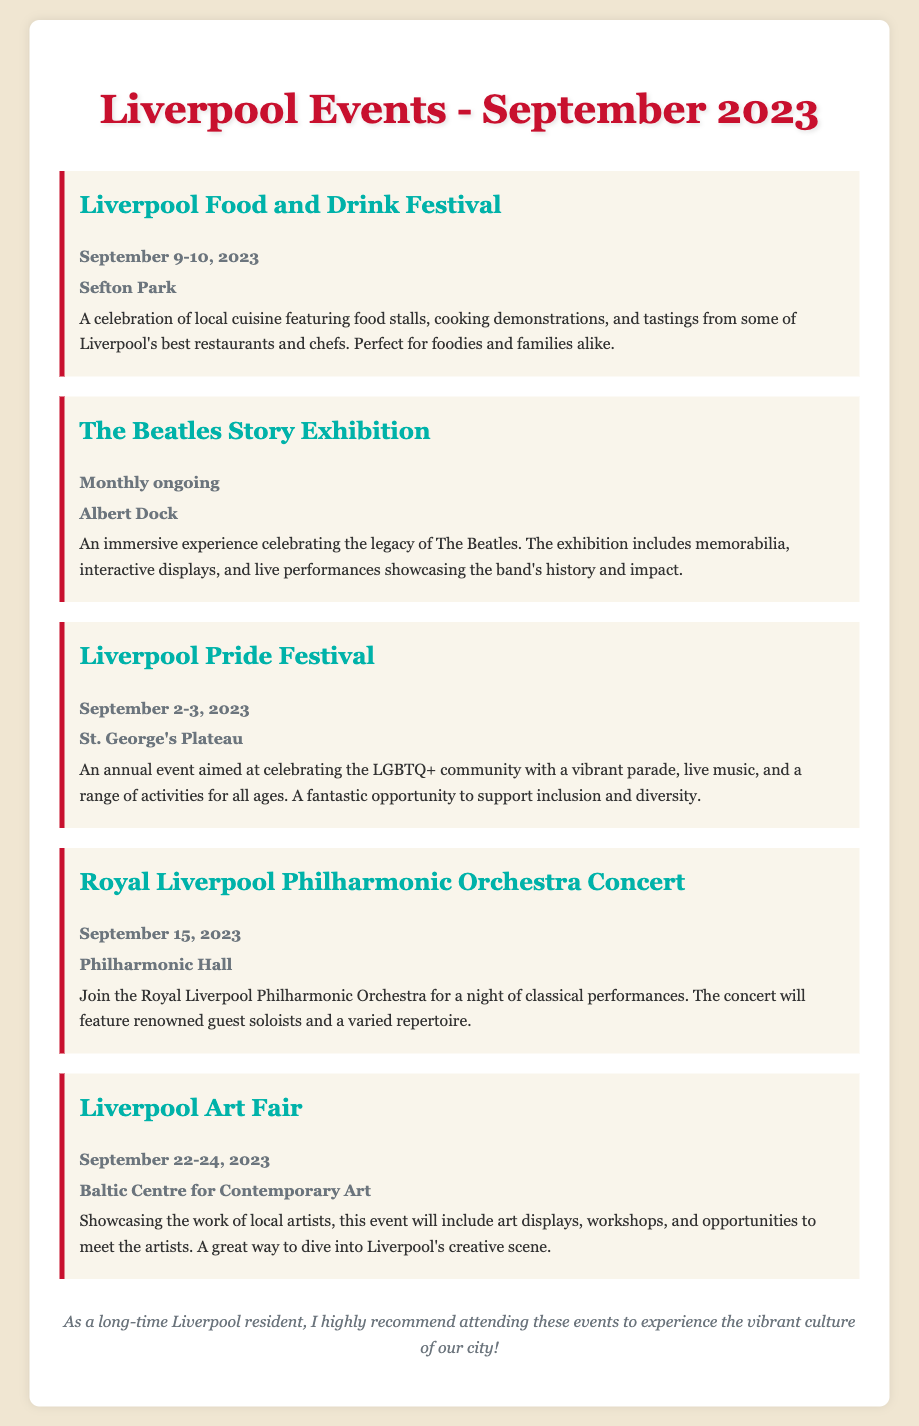What event is taking place on September 9-10, 2023? The event specified for those dates is the Liverpool Food and Drink Festival.
Answer: Liverpool Food and Drink Festival Where is the Beatles Story Exhibition located? The Beatles Story Exhibition is held at Albert Dock.
Answer: Albert Dock What date does the Liverpool Pride Festival occur? The Liverpool Pride Festival is scheduled for September 2-3, 2023.
Answer: September 2-3, 2023 What type of event is the Liverpool Art Fair? The Liverpool Art Fair showcases the work of local artists.
Answer: Showcasing the work of local artists Who is performing at the Royal Liverpool Philharmonic Orchestra Concert on September 15, 2023? The concert features renowned guest soloists.
Answer: Renowned guest soloists How long is the Beatles Story Exhibition ongoing? The Beatles Story Exhibition is an ongoing event, happening monthly.
Answer: Monthly ongoing 